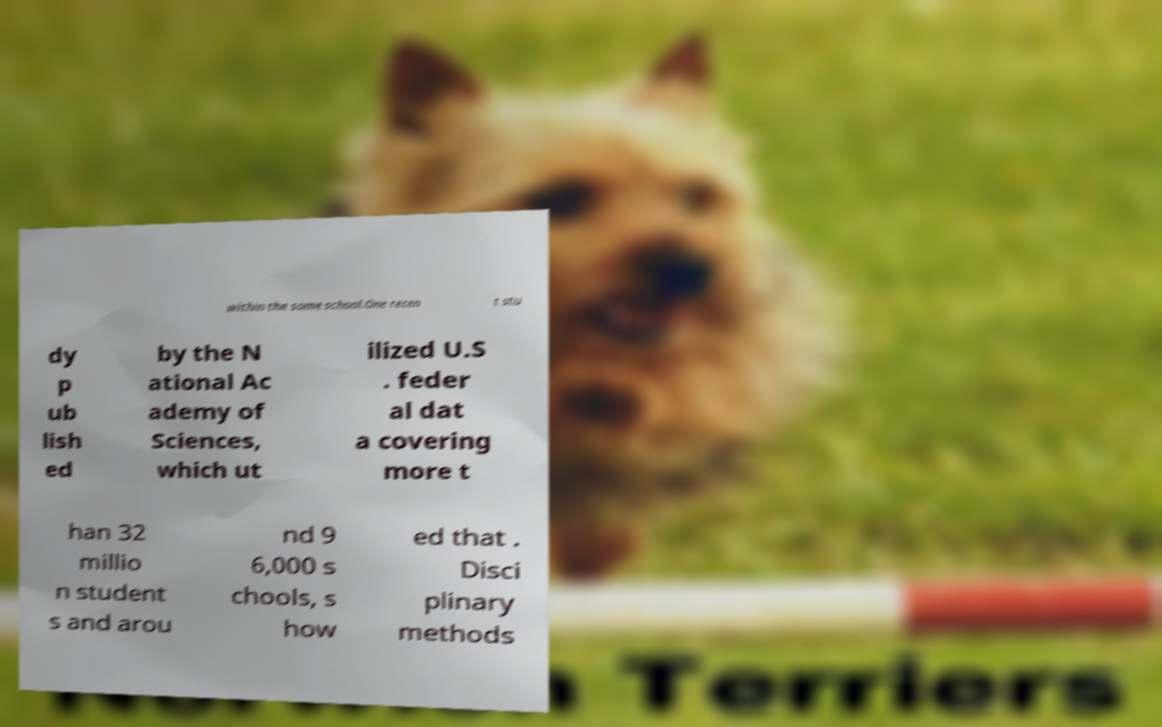I need the written content from this picture converted into text. Can you do that? within the same school.One recen t stu dy p ub lish ed by the N ational Ac ademy of Sciences, which ut ilized U.S . feder al dat a covering more t han 32 millio n student s and arou nd 9 6,000 s chools, s how ed that . Disci plinary methods 